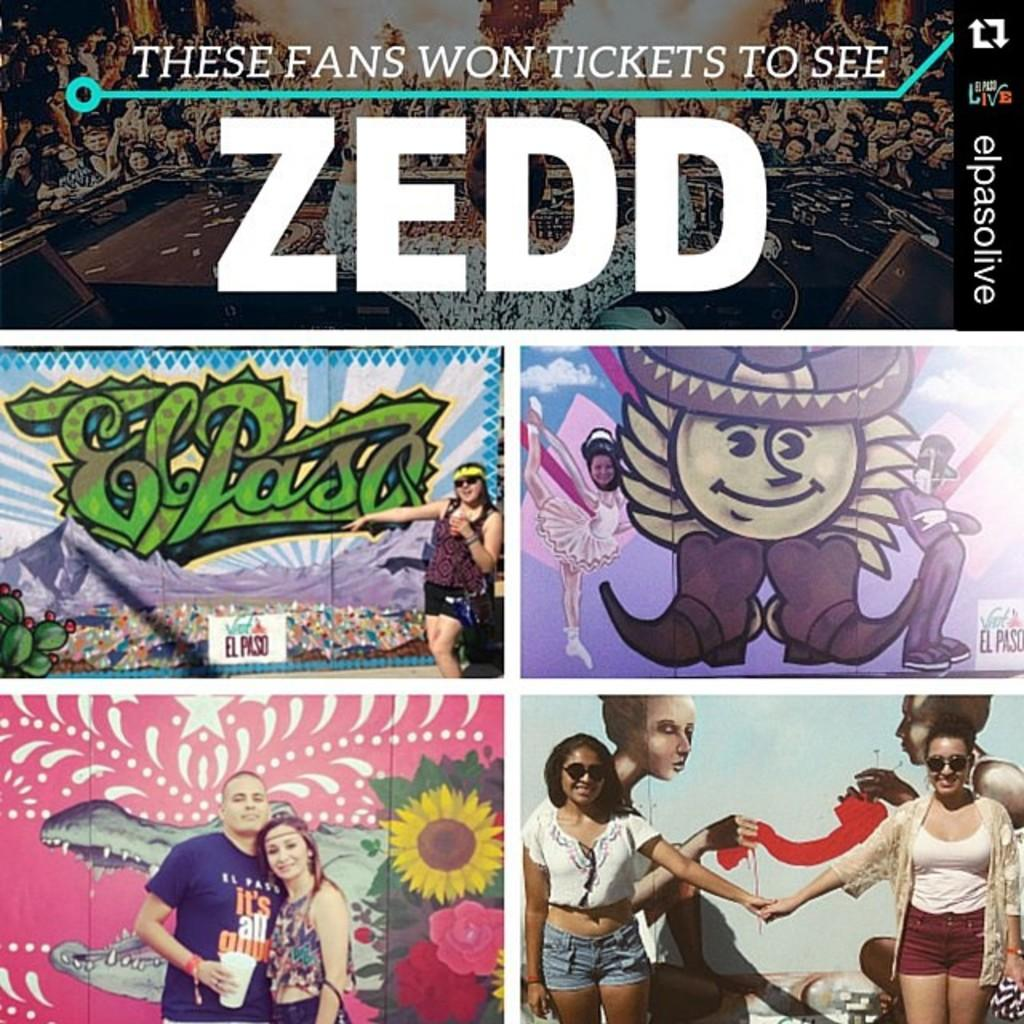<image>
Share a concise interpretation of the image provided. An ad for Zedd says These Fans Won Tickets To See Zedd and shows walls with paintings on them. 